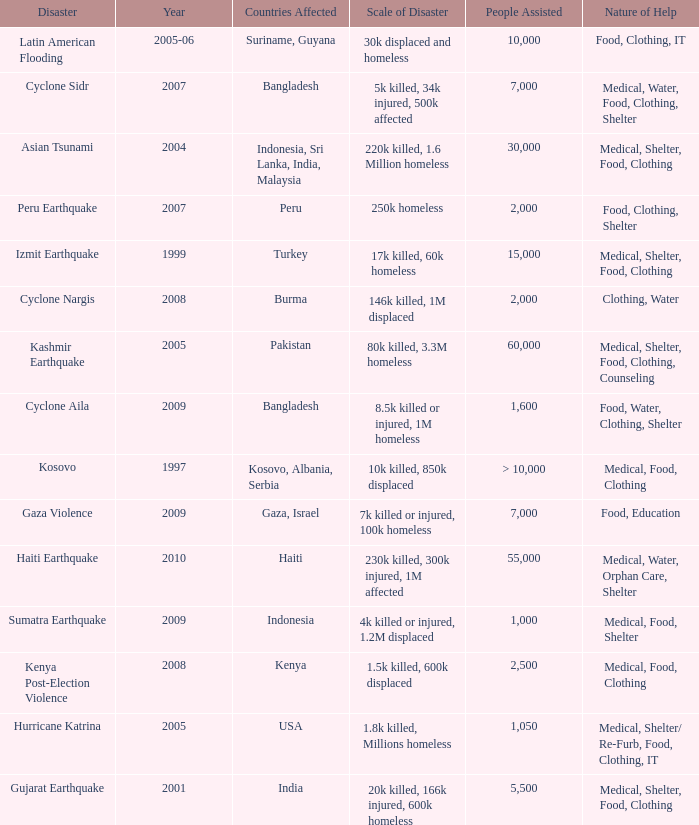How many people were assisted in 1997? > 10,000. 